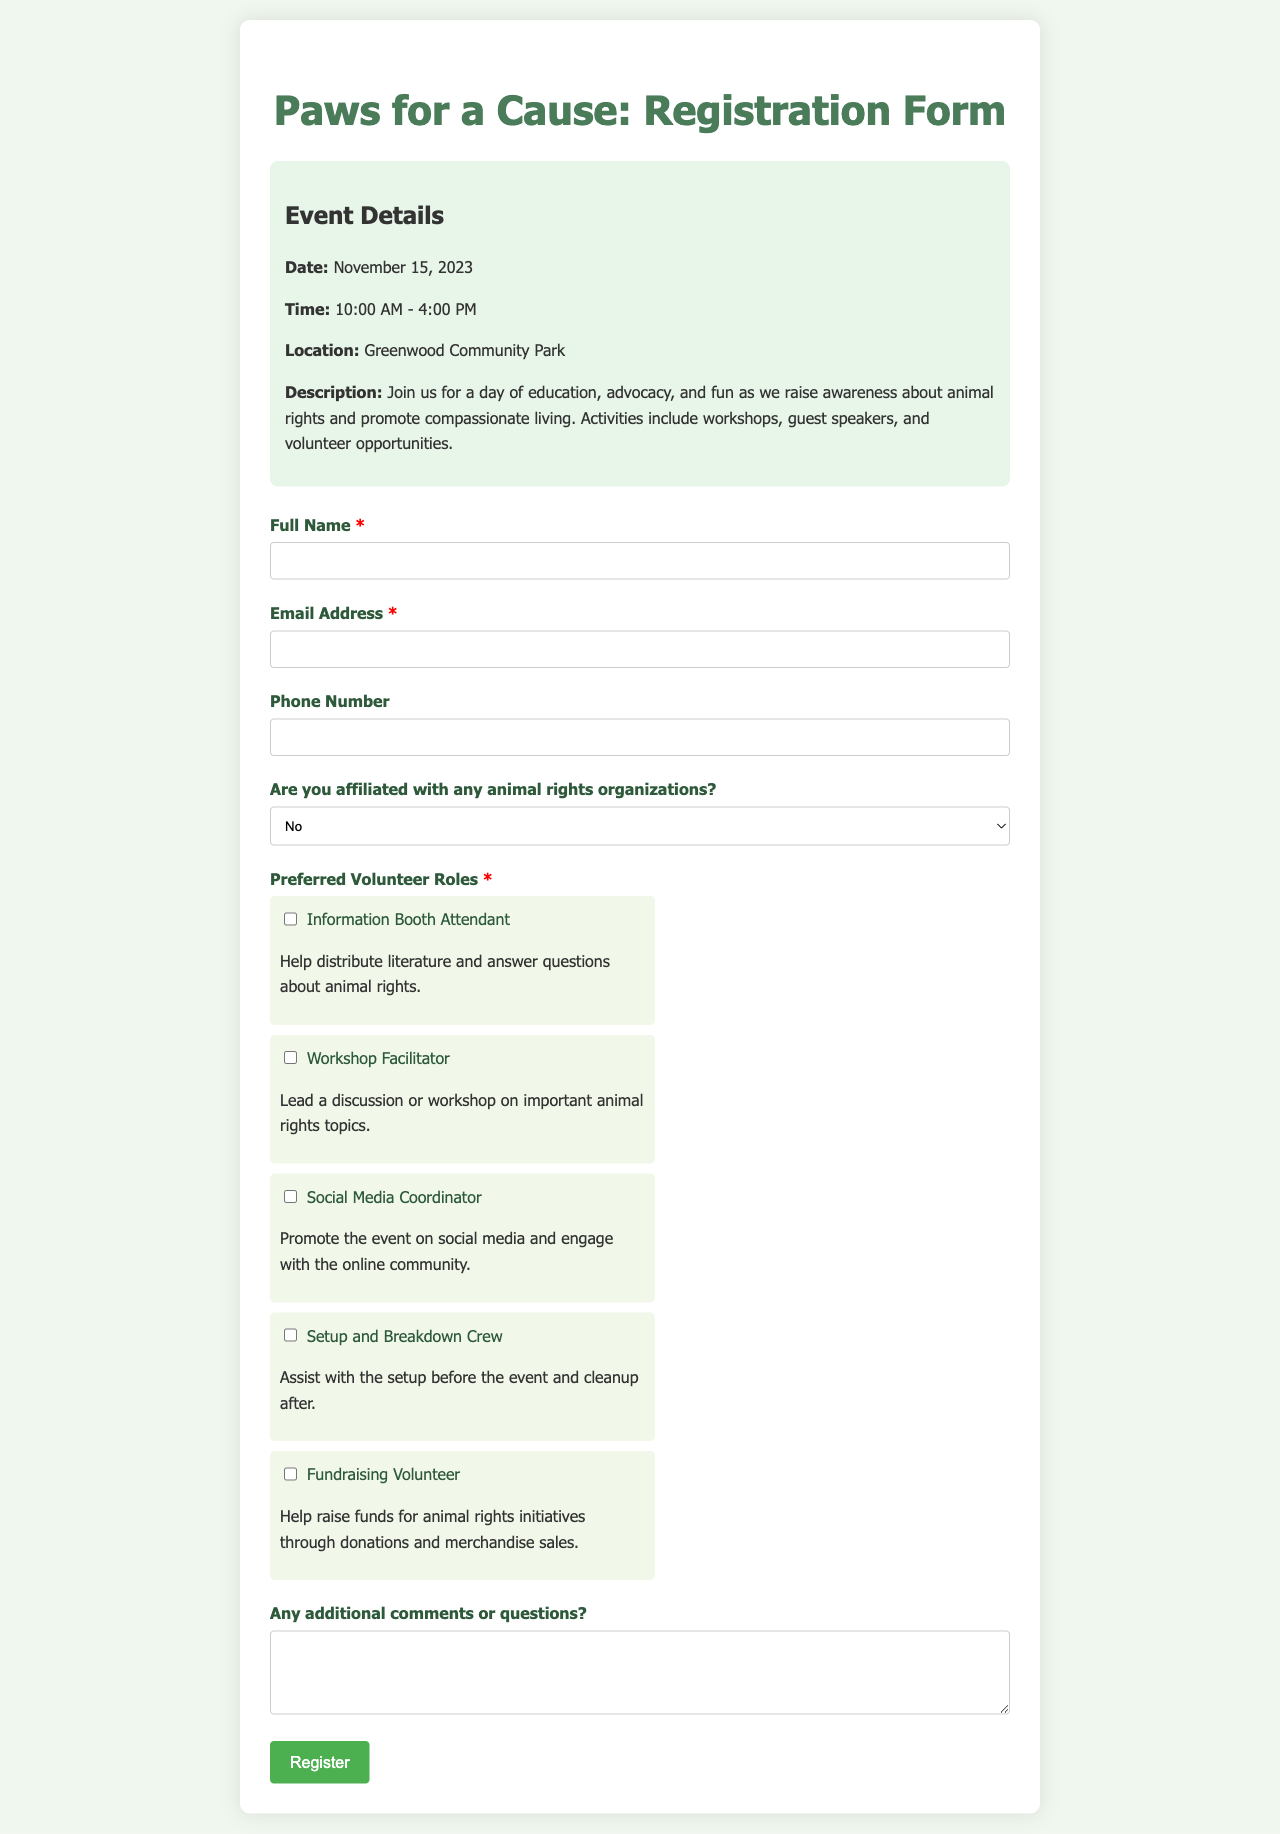What is the date of the event? The date of the event is mentioned in the event details section of the document.
Answer: November 15, 2023 What is the time of the event? The time of the event is specified in the event details section of the document.
Answer: 10:00 AM - 4:00 PM Where is the event being held? The location of the event is clearly stated in the event details section of the document.
Answer: Greenwood Community Park What are the roles participants can volunteer for? This can be found in the preferred volunteer roles section where various options are listed.
Answer: Information Booth Attendant, Workshop Facilitator, Social Media Coordinator, Setup and Breakdown Crew, Fundraising Volunteer Is there a required field in the registration form? The form specifies required fields through the usage of the "required" class next to labels.
Answer: Full Name, Email Address What type of comment can participants leave? The document includes a section allowing for additional comments or questions from participants.
Answer: Any additional comments or questions How should participants submit the registration form? The form submission process is described in the JavaScript part of the document.
Answer: By clicking the register button What happens if a participant does not select a volunteer role? The JavaScript code indicates an alert warning if no role is selected.
Answer: Alert message is triggered 